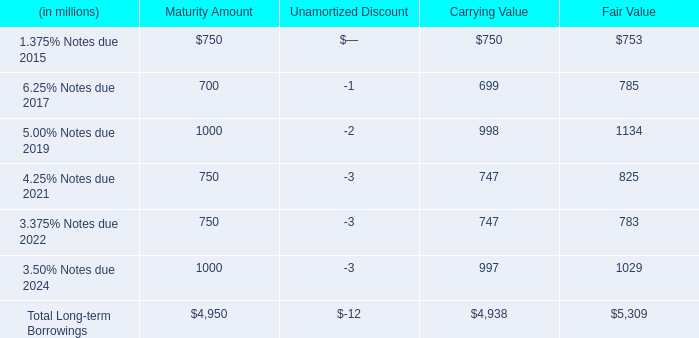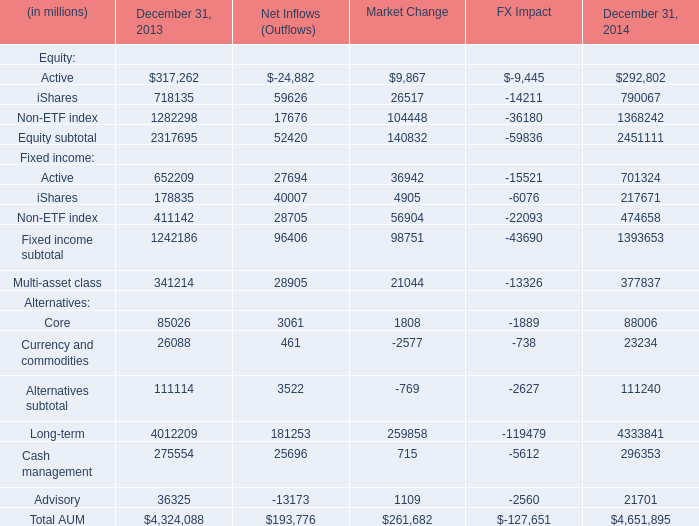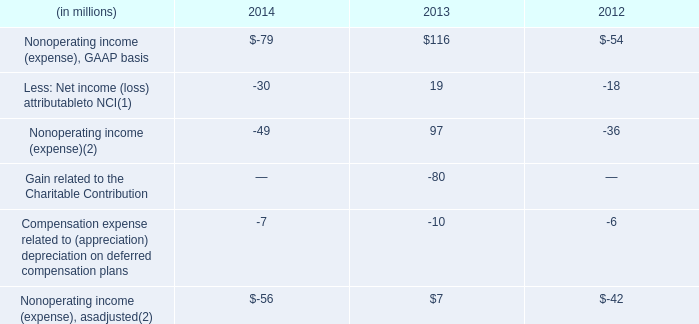what is the growth rate in employee headcount from 2012 to 2013? 
Computations: ((11400 - 10500) / 10500)
Answer: 0.08571. 